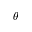Convert formula to latex. <formula><loc_0><loc_0><loc_500><loc_500>\theta</formula> 